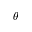Convert formula to latex. <formula><loc_0><loc_0><loc_500><loc_500>\theta</formula> 